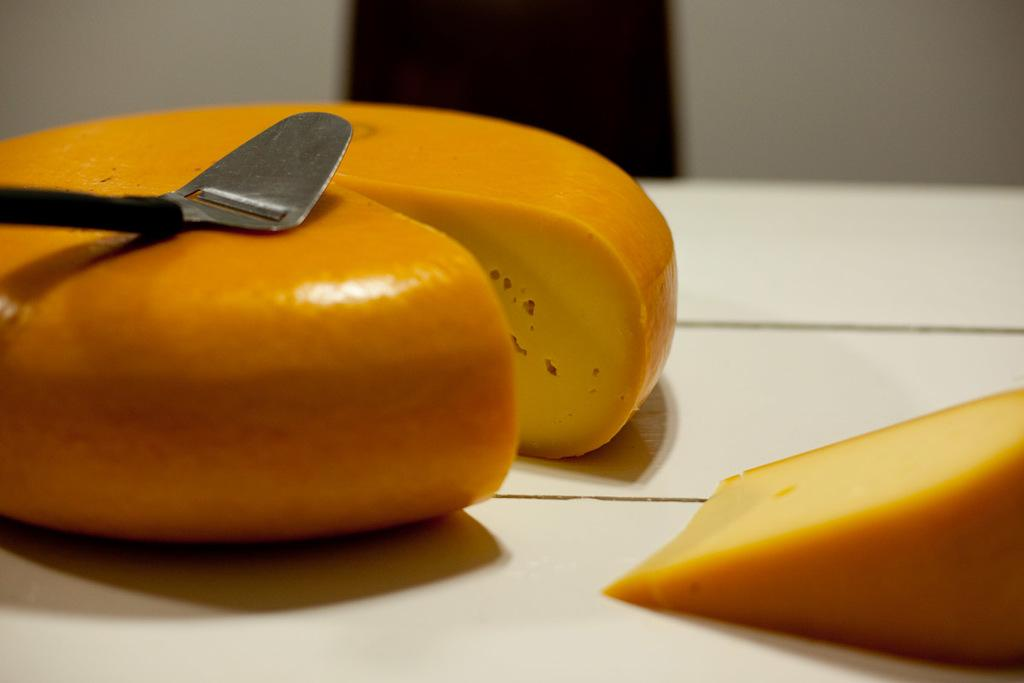What is the main subject of the image? There is a food item in the image. What utensil is present in the image? A spoon is present in the image. Where are the food item and spoon located? The food item and spoon are on a table. What can be seen in the background of the image? There is a door and a wall in the background of the image. What type of vest is visible on the food item in the image? There is no vest present on the food item in the image. Can you describe the field where the food item is located in the image? There is no field present in the image; it is set indoors with a table, food item, spoon, door, and wall. 